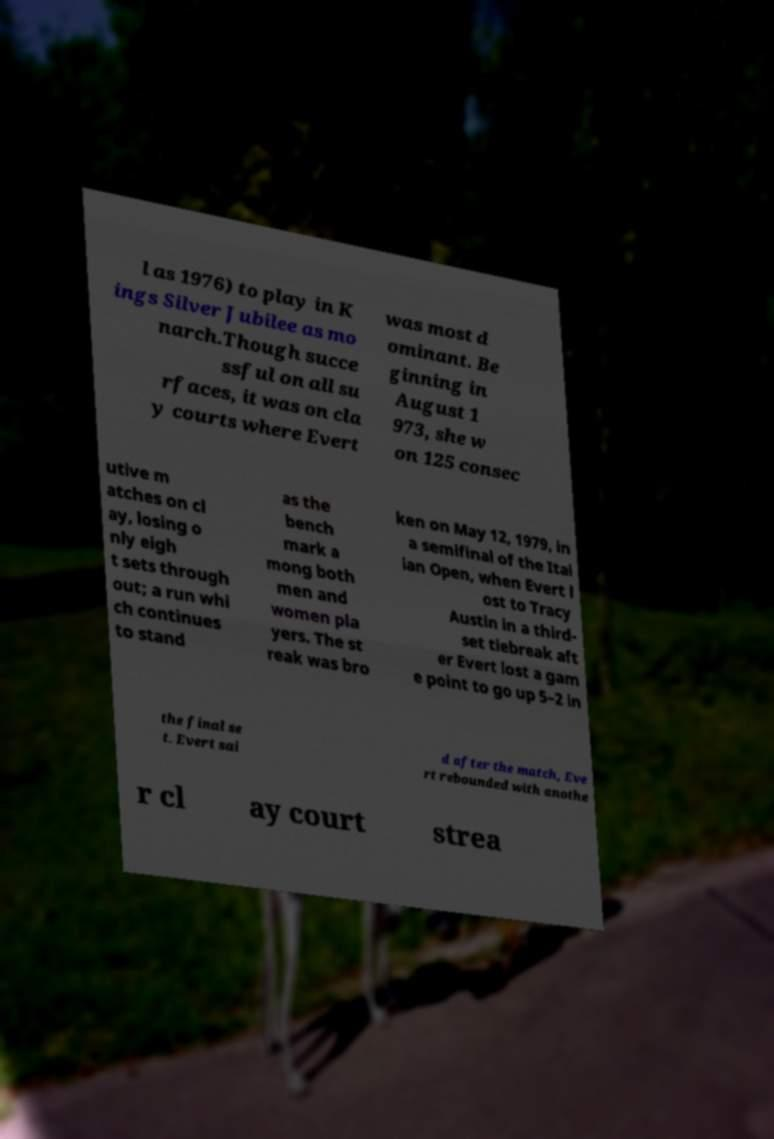Can you read and provide the text displayed in the image?This photo seems to have some interesting text. Can you extract and type it out for me? l as 1976) to play in K ings Silver Jubilee as mo narch.Though succe ssful on all su rfaces, it was on cla y courts where Evert was most d ominant. Be ginning in August 1 973, she w on 125 consec utive m atches on cl ay, losing o nly eigh t sets through out; a run whi ch continues to stand as the bench mark a mong both men and women pla yers. The st reak was bro ken on May 12, 1979, in a semifinal of the Ital ian Open, when Evert l ost to Tracy Austin in a third- set tiebreak aft er Evert lost a gam e point to go up 5–2 in the final se t. Evert sai d after the match, Eve rt rebounded with anothe r cl ay court strea 